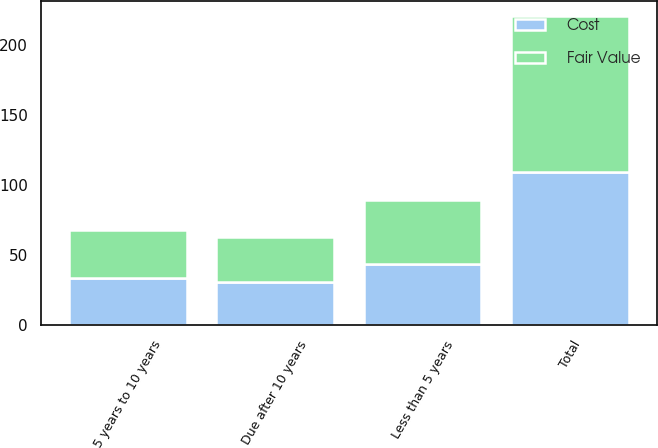<chart> <loc_0><loc_0><loc_500><loc_500><stacked_bar_chart><ecel><fcel>Less than 5 years<fcel>5 years to 10 years<fcel>Due after 10 years<fcel>Total<nl><fcel>Cost<fcel>44<fcel>34<fcel>31<fcel>109<nl><fcel>Fair Value<fcel>45<fcel>34<fcel>32<fcel>111<nl></chart> 